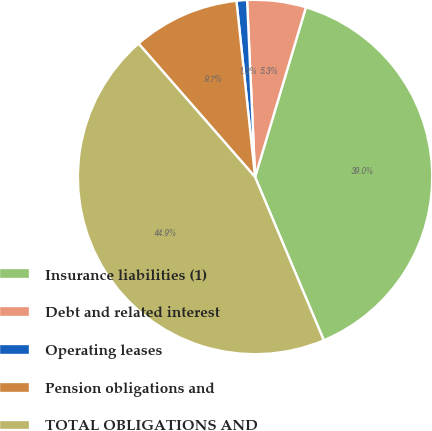Convert chart to OTSL. <chart><loc_0><loc_0><loc_500><loc_500><pie_chart><fcel>Insurance liabilities (1)<fcel>Debt and related interest<fcel>Operating leases<fcel>Pension obligations and<fcel>TOTAL OBLIGATIONS AND<nl><fcel>39.03%<fcel>5.35%<fcel>0.96%<fcel>9.75%<fcel>44.92%<nl></chart> 